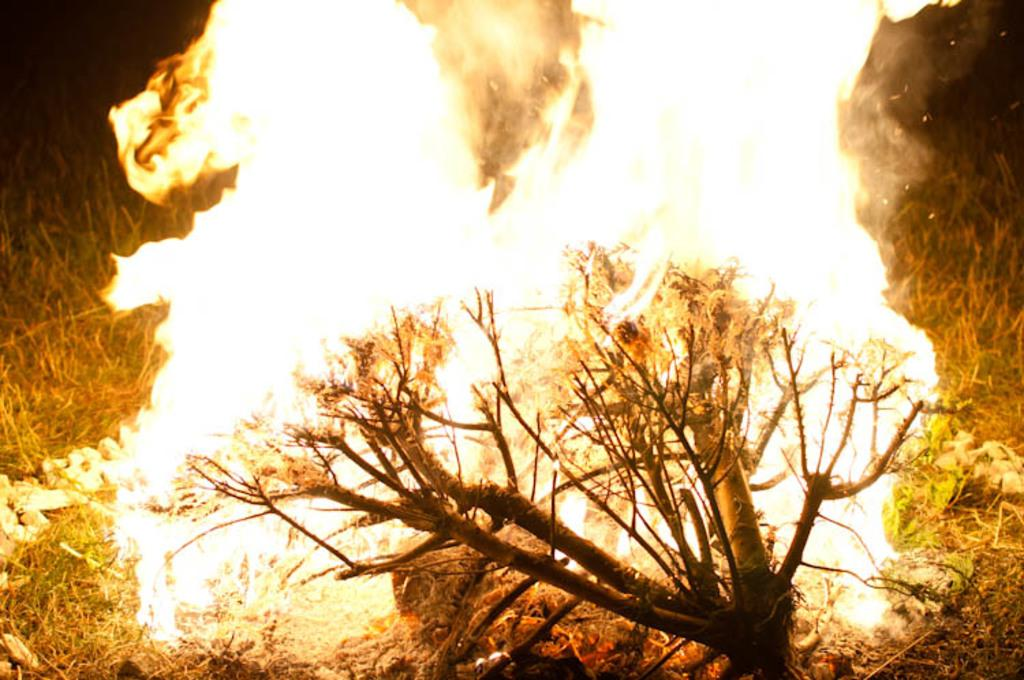What is the primary element in the image? There is a flame in the image. What other natural elements can be seen in the image? There is a tree branch and grass visible in the image. What is the color of the background in the image? The background of the image is dark. What type of whip can be seen being used in the image? There is no whip present in the image. What unit of measurement is used to describe the size of the flame in the image? The facts provided do not include any information about the size of the flame, so it is not possible to determine the unit of measurement used. 